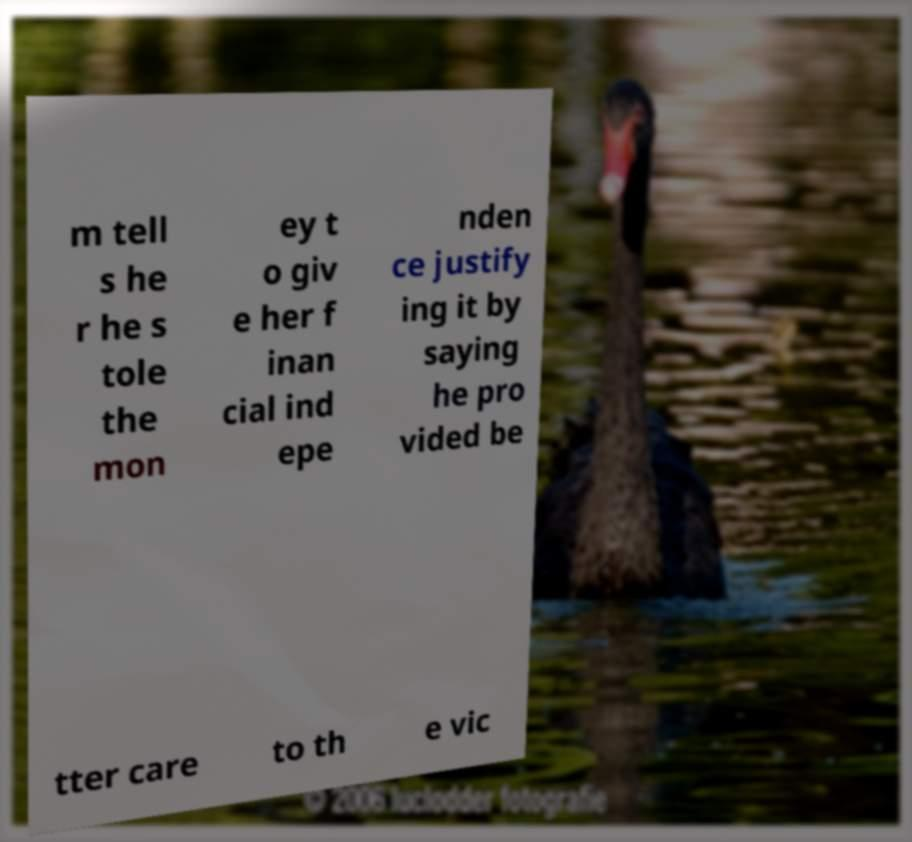Please read and relay the text visible in this image. What does it say? m tell s he r he s tole the mon ey t o giv e her f inan cial ind epe nden ce justify ing it by saying he pro vided be tter care to th e vic 